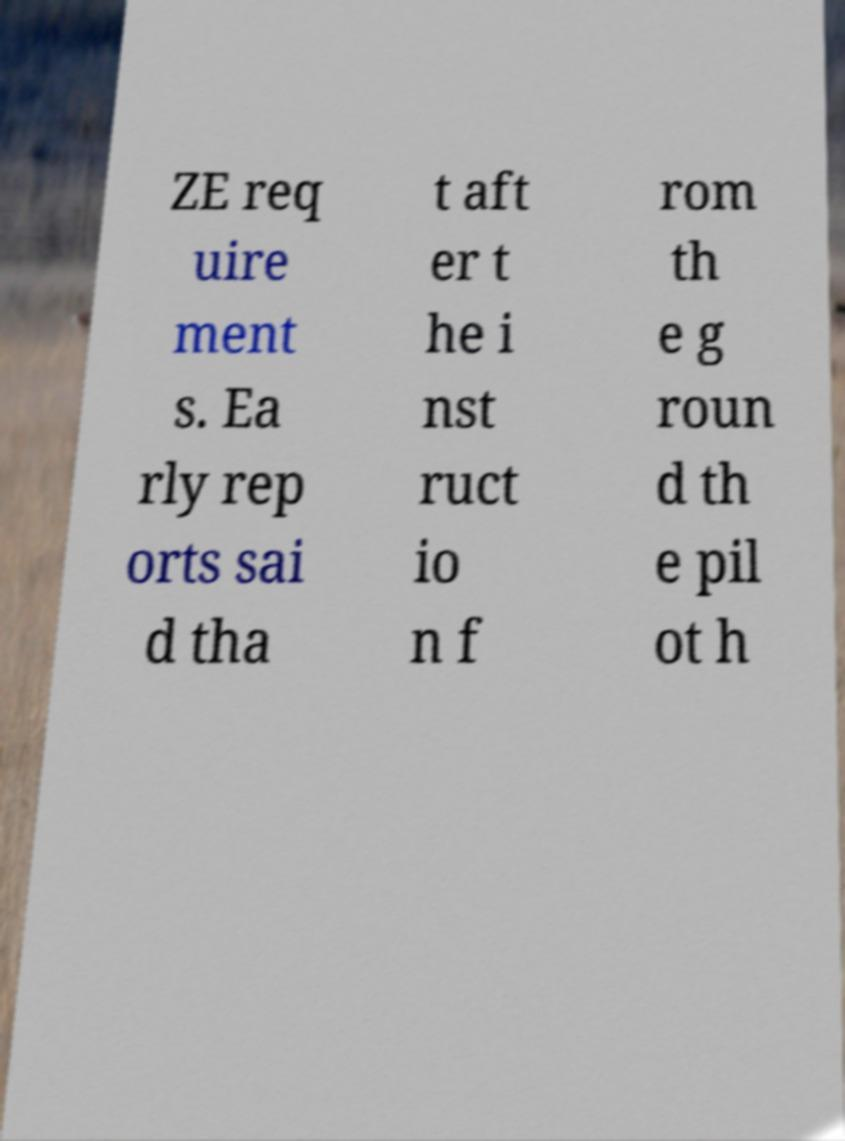Could you extract and type out the text from this image? ZE req uire ment s. Ea rly rep orts sai d tha t aft er t he i nst ruct io n f rom th e g roun d th e pil ot h 